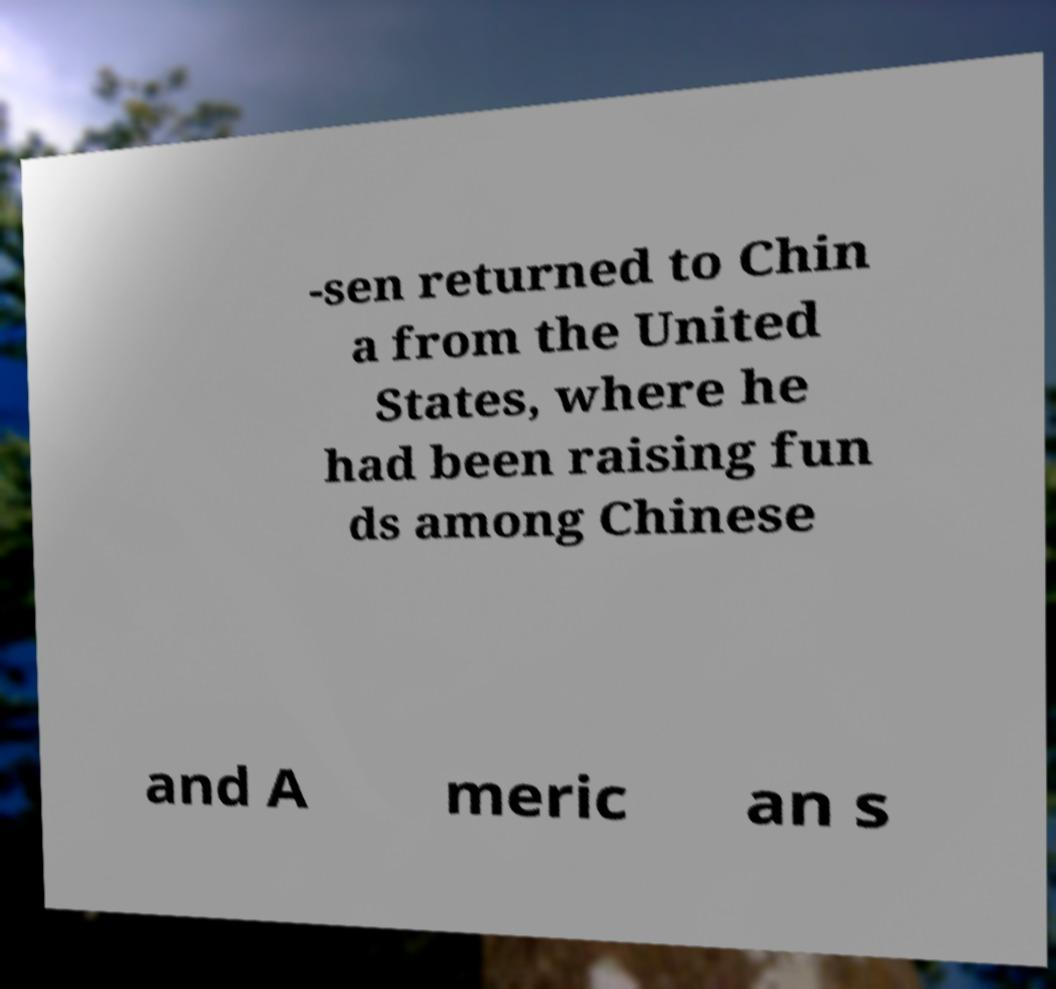Could you extract and type out the text from this image? -sen returned to Chin a from the United States, where he had been raising fun ds among Chinese and A meric an s 